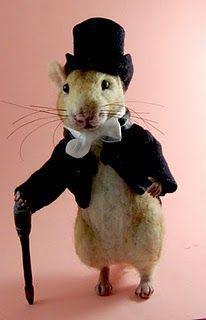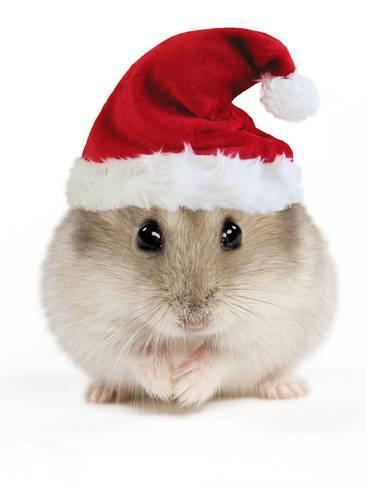The first image is the image on the left, the second image is the image on the right. For the images shown, is this caption "Exactly one guinea pig is wearing a top hat." true? Answer yes or no. Yes. The first image is the image on the left, the second image is the image on the right. Assess this claim about the two images: "The rodent in the image on the left is standing while wearing a top hat.". Correct or not? Answer yes or no. Yes. 